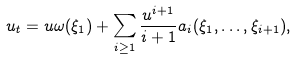<formula> <loc_0><loc_0><loc_500><loc_500>u _ { t } = u \omega ( \xi _ { 1 } ) + \sum _ { i \geq 1 } \frac { u ^ { i + 1 } } { i + 1 } a _ { i } ( \xi _ { 1 } , \dots , \xi _ { i + 1 } ) ,</formula> 